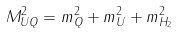<formula> <loc_0><loc_0><loc_500><loc_500>M _ { U Q } ^ { 2 } = m _ { Q } ^ { 2 } + m _ { U } ^ { 2 } + m _ { H _ { 2 } } ^ { 2 }</formula> 